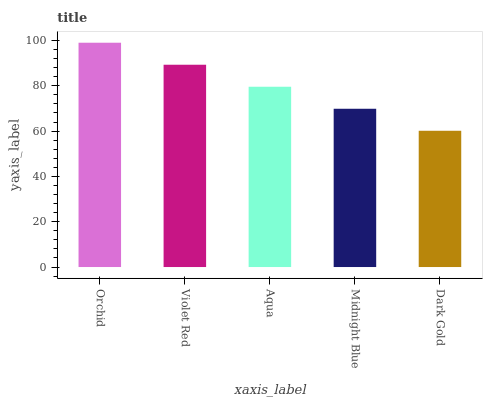Is Dark Gold the minimum?
Answer yes or no. Yes. Is Orchid the maximum?
Answer yes or no. Yes. Is Violet Red the minimum?
Answer yes or no. No. Is Violet Red the maximum?
Answer yes or no. No. Is Orchid greater than Violet Red?
Answer yes or no. Yes. Is Violet Red less than Orchid?
Answer yes or no. Yes. Is Violet Red greater than Orchid?
Answer yes or no. No. Is Orchid less than Violet Red?
Answer yes or no. No. Is Aqua the high median?
Answer yes or no. Yes. Is Aqua the low median?
Answer yes or no. Yes. Is Violet Red the high median?
Answer yes or no. No. Is Violet Red the low median?
Answer yes or no. No. 